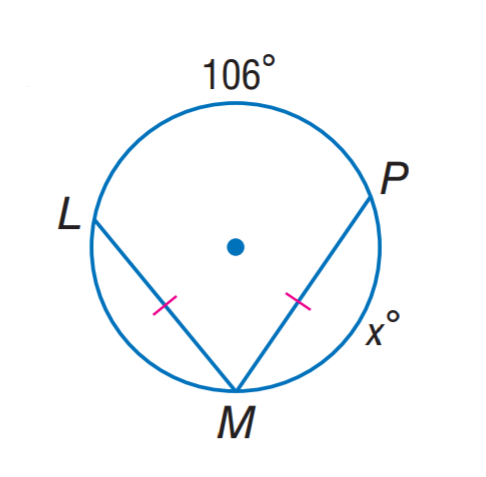Answer the mathemtical geometry problem and directly provide the correct option letter.
Question: Find x.
Choices: A: 53 B: 84 C: 106 D: 127 D 